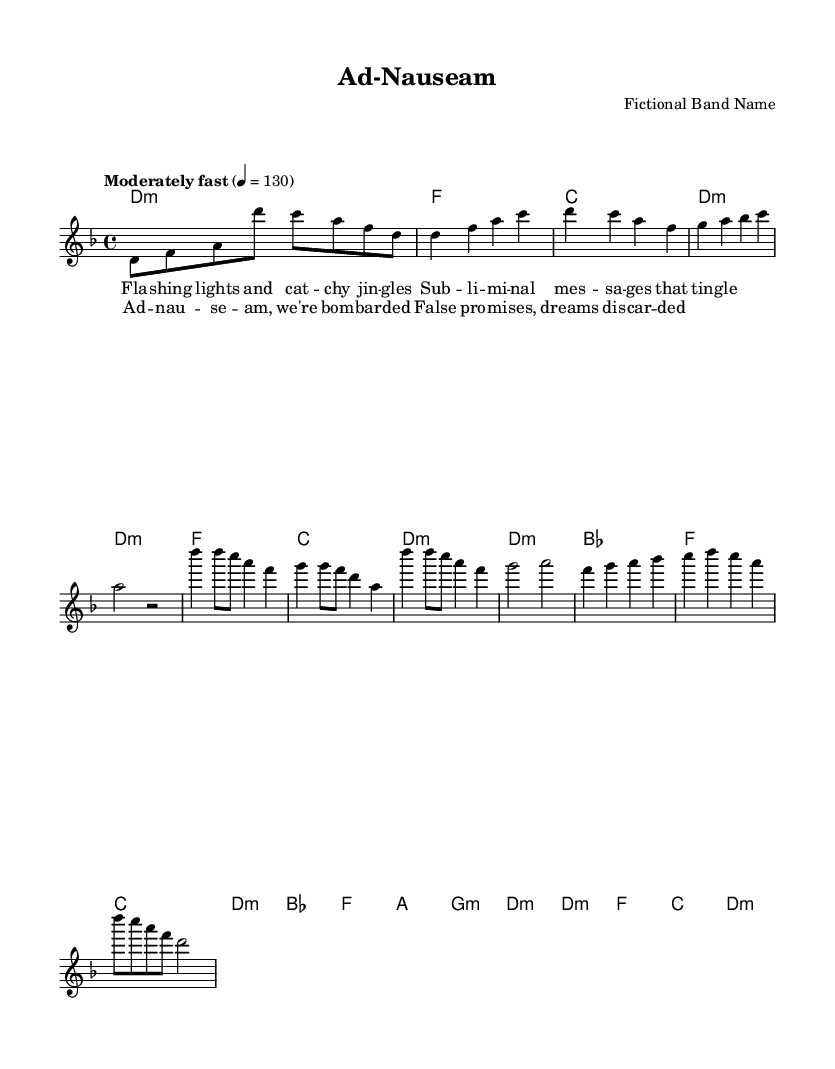what is the key signature of this music? The key signature is D minor, which has one flat. This can be identified on the left side of the staff where the note B flat is indicated.
Answer: D minor what is the time signature of this music? The time signature is 4/4, which can be found at the beginning of the sheet music right after the key signature. This indicates four beats per measure.
Answer: 4/4 what is the tempo marking of this piece? The tempo marking is "Moderately fast" with a metronome indication of 130 beats per minute. This is indicated above the staff.
Answer: Moderately fast how many measures are in the chorus section? The chorus is composed of four measures, as can be counted from the corresponding notation in the sheet music. Each separate group of notes separated by vertical lines indicates a measure.
Answer: 4 what is the structure of the song in terms of sections? The song consists of an Intro, Verse 1, Chorus, Bridge, and Outro. This can be deduced from the distinct parts labeled in the melody section, each representing different parts of the song.
Answer: Intro, Verse 1, Chorus, Bridge, Outro what chords are used in the chorus section? The chords in the chorus are D minor, B flat, F, and C. This can be confirmed by reading the chord names aligned with the melody notes in the chorus part.
Answer: D minor, B flat, F, C 